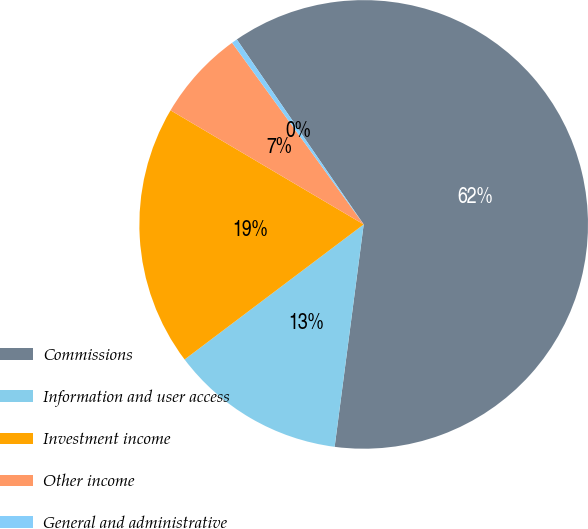Convert chart to OTSL. <chart><loc_0><loc_0><loc_500><loc_500><pie_chart><fcel>Commissions<fcel>Information and user access<fcel>Investment income<fcel>Other income<fcel>General and administrative<nl><fcel>61.64%<fcel>12.65%<fcel>18.78%<fcel>6.53%<fcel>0.41%<nl></chart> 